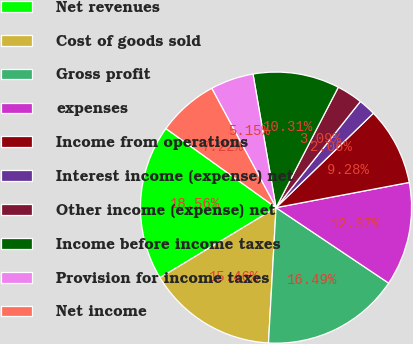Convert chart. <chart><loc_0><loc_0><loc_500><loc_500><pie_chart><fcel>Net revenues<fcel>Cost of goods sold<fcel>Gross profit<fcel>expenses<fcel>Income from operations<fcel>Interest income (expense) net<fcel>Other income (expense) net<fcel>Income before income taxes<fcel>Provision for income taxes<fcel>Net income<nl><fcel>18.56%<fcel>15.46%<fcel>16.49%<fcel>12.37%<fcel>9.28%<fcel>2.06%<fcel>3.09%<fcel>10.31%<fcel>5.15%<fcel>7.22%<nl></chart> 